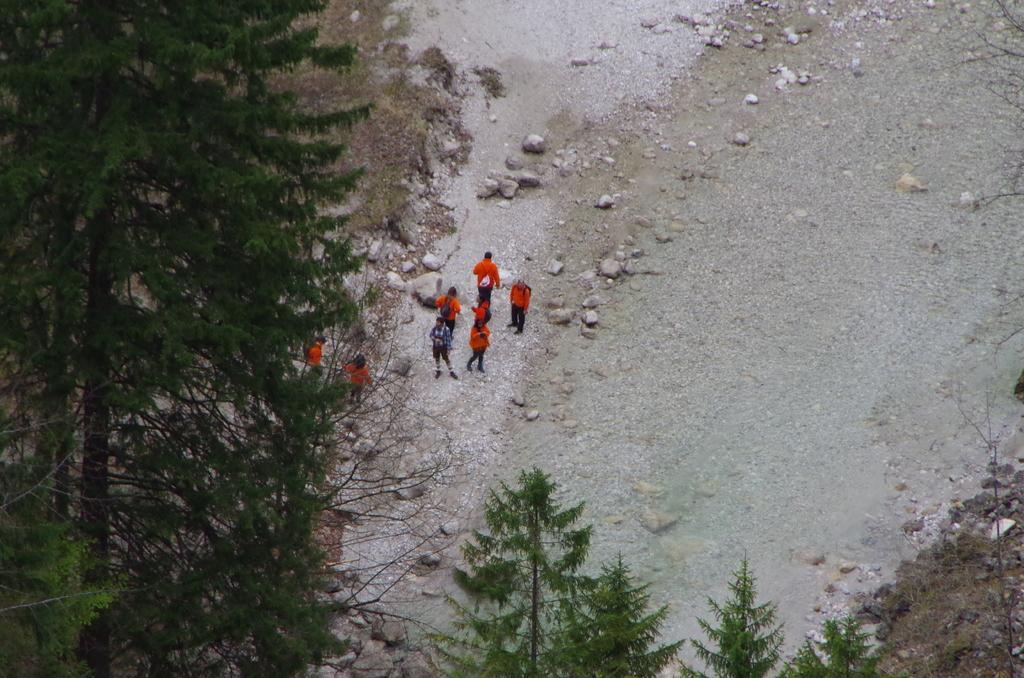Can you describe this image briefly? On the left side of the image and at the bottom of the image there are trees. In the middle of the image there are people and rocks. 